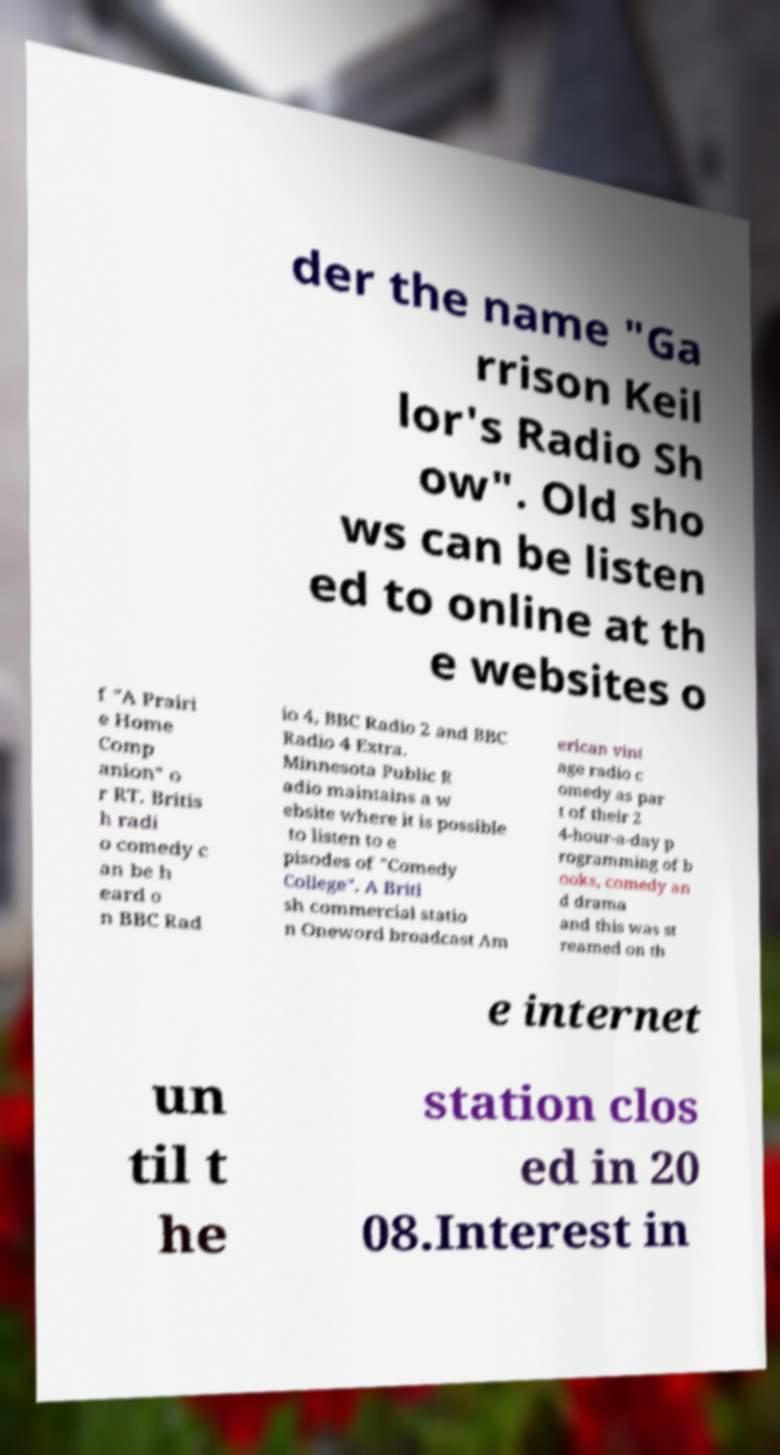For documentation purposes, I need the text within this image transcribed. Could you provide that? der the name "Ga rrison Keil lor's Radio Sh ow". Old sho ws can be listen ed to online at th e websites o f "A Prairi e Home Comp anion" o r RT. Britis h radi o comedy c an be h eard o n BBC Rad io 4, BBC Radio 2 and BBC Radio 4 Extra. Minnesota Public R adio maintains a w ebsite where it is possible to listen to e pisodes of "Comedy College". A Briti sh commercial statio n Oneword broadcast Am erican vint age radio c omedy as par t of their 2 4-hour-a-day p rogramming of b ooks, comedy an d drama and this was st reamed on th e internet un til t he station clos ed in 20 08.Interest in 